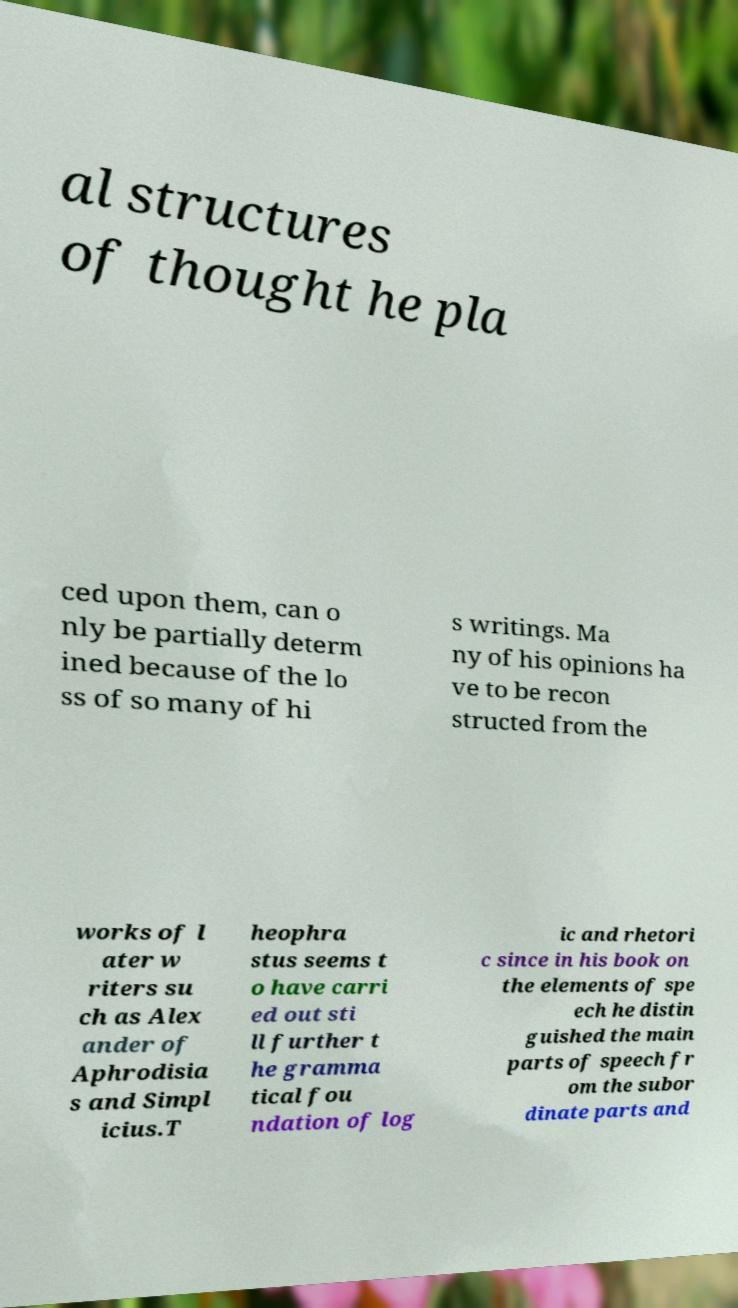There's text embedded in this image that I need extracted. Can you transcribe it verbatim? al structures of thought he pla ced upon them, can o nly be partially determ ined because of the lo ss of so many of hi s writings. Ma ny of his opinions ha ve to be recon structed from the works of l ater w riters su ch as Alex ander of Aphrodisia s and Simpl icius.T heophra stus seems t o have carri ed out sti ll further t he gramma tical fou ndation of log ic and rhetori c since in his book on the elements of spe ech he distin guished the main parts of speech fr om the subor dinate parts and 